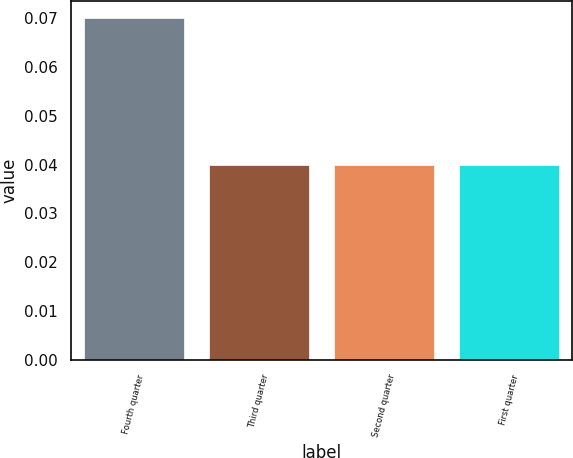Convert chart. <chart><loc_0><loc_0><loc_500><loc_500><bar_chart><fcel>Fourth quarter<fcel>Third quarter<fcel>Second quarter<fcel>First quarter<nl><fcel>0.07<fcel>0.04<fcel>0.04<fcel>0.04<nl></chart> 